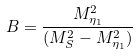Convert formula to latex. <formula><loc_0><loc_0><loc_500><loc_500>B = \frac { M _ { \eta _ { 1 } } ^ { 2 } } { ( M _ { S } ^ { 2 } - M _ { \eta _ { 1 } } ^ { 2 } ) }</formula> 